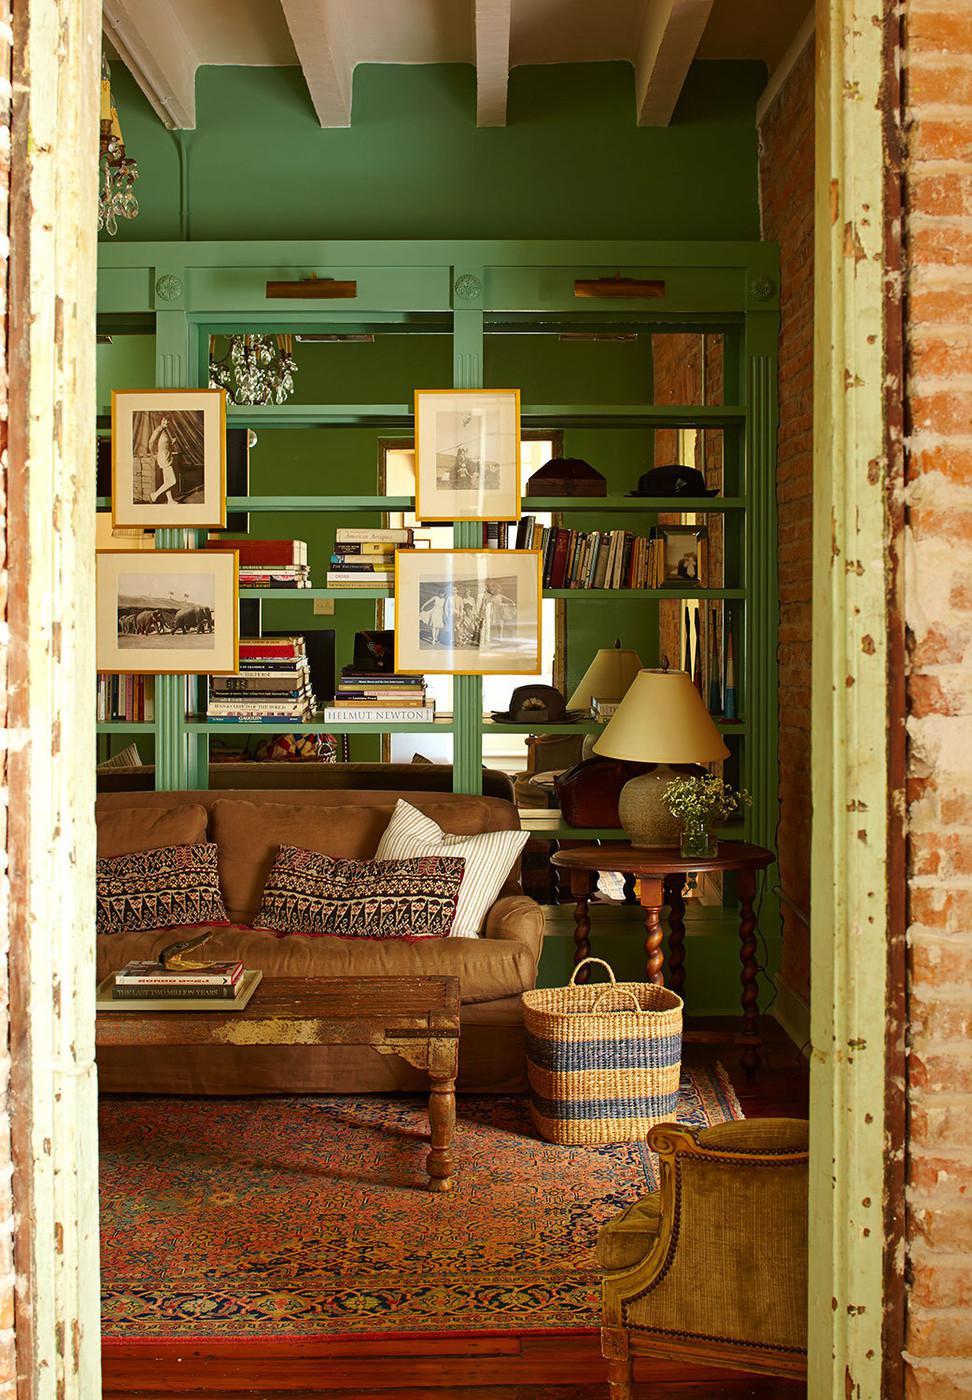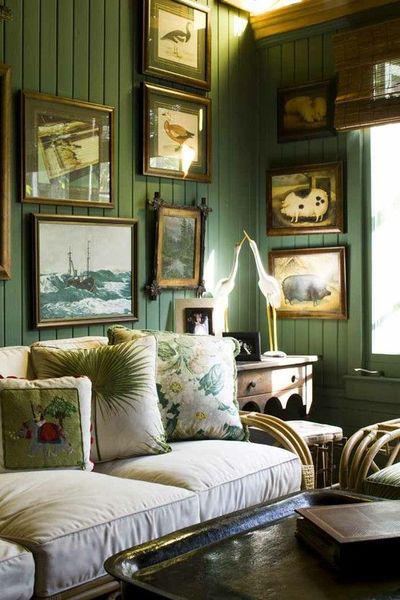The first image is the image on the left, the second image is the image on the right. Given the left and right images, does the statement "The left image shows framed pictures on the front of green bookshelves in front of a green wall, and a brown sofa in front of the bookshelves." hold true? Answer yes or no. Yes. The first image is the image on the left, the second image is the image on the right. Evaluate the accuracy of this statement regarding the images: "In at least one image there is a green wall with at least two framed pictures.". Is it true? Answer yes or no. Yes. 